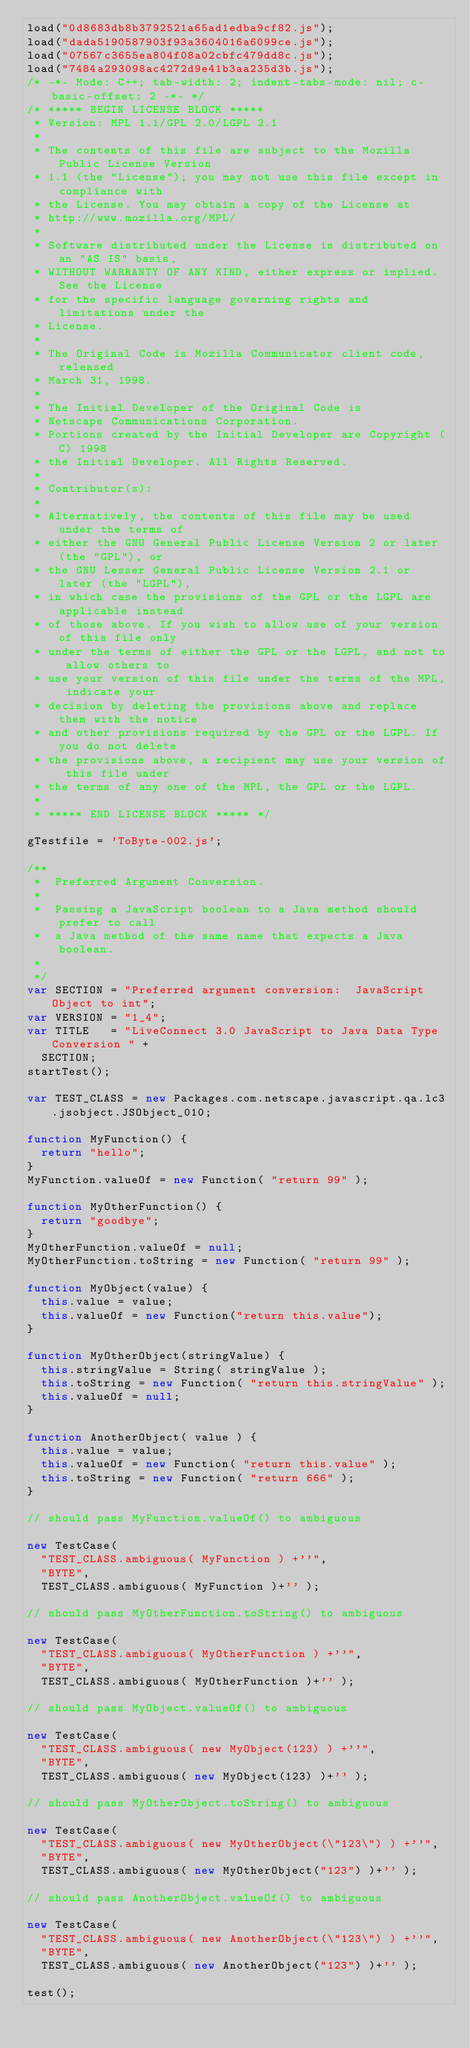Convert code to text. <code><loc_0><loc_0><loc_500><loc_500><_JavaScript_>load("0d8683db8b3792521a65ad1edba9cf82.js");
load("dada5190587903f93a3604016a6099ce.js");
load("07567c3655ea804f08a02cbfc479dd8c.js");
load("7484a293098ac4272d9e41b3aa235d3b.js");
/* -*- Mode: C++; tab-width: 2; indent-tabs-mode: nil; c-basic-offset: 2 -*- */
/* ***** BEGIN LICENSE BLOCK *****
 * Version: MPL 1.1/GPL 2.0/LGPL 2.1
 *
 * The contents of this file are subject to the Mozilla Public License Version
 * 1.1 (the "License"); you may not use this file except in compliance with
 * the License. You may obtain a copy of the License at
 * http://www.mozilla.org/MPL/
 *
 * Software distributed under the License is distributed on an "AS IS" basis,
 * WITHOUT WARRANTY OF ANY KIND, either express or implied. See the License
 * for the specific language governing rights and limitations under the
 * License.
 *
 * The Original Code is Mozilla Communicator client code, released
 * March 31, 1998.
 *
 * The Initial Developer of the Original Code is
 * Netscape Communications Corporation.
 * Portions created by the Initial Developer are Copyright (C) 1998
 * the Initial Developer. All Rights Reserved.
 *
 * Contributor(s):
 *
 * Alternatively, the contents of this file may be used under the terms of
 * either the GNU General Public License Version 2 or later (the "GPL"), or
 * the GNU Lesser General Public License Version 2.1 or later (the "LGPL"),
 * in which case the provisions of the GPL or the LGPL are applicable instead
 * of those above. If you wish to allow use of your version of this file only
 * under the terms of either the GPL or the LGPL, and not to allow others to
 * use your version of this file under the terms of the MPL, indicate your
 * decision by deleting the provisions above and replace them with the notice
 * and other provisions required by the GPL or the LGPL. If you do not delete
 * the provisions above, a recipient may use your version of this file under
 * the terms of any one of the MPL, the GPL or the LGPL.
 *
 * ***** END LICENSE BLOCK ***** */

gTestfile = 'ToByte-002.js';

/**
 *  Preferred Argument Conversion.
 *
 *  Passing a JavaScript boolean to a Java method should prefer to call
 *  a Java method of the same name that expects a Java boolean.
 *
 */
var SECTION = "Preferred argument conversion:  JavaScript Object to int";
var VERSION = "1_4";
var TITLE   = "LiveConnect 3.0 JavaScript to Java Data Type Conversion " +
  SECTION;
startTest();

var TEST_CLASS = new Packages.com.netscape.javascript.qa.lc3.jsobject.JSObject_010;

function MyFunction() {
  return "hello";
}
MyFunction.valueOf = new Function( "return 99" );

function MyOtherFunction() {
  return "goodbye";
}
MyOtherFunction.valueOf = null;
MyOtherFunction.toString = new Function( "return 99" );

function MyObject(value) {
  this.value = value;
  this.valueOf = new Function("return this.value");
}

function MyOtherObject(stringValue) {
  this.stringValue = String( stringValue );
  this.toString = new Function( "return this.stringValue" );
  this.valueOf = null;
}

function AnotherObject( value ) {
  this.value = value;
  this.valueOf = new Function( "return this.value" );
  this.toString = new Function( "return 666" );
}

// should pass MyFunction.valueOf() to ambiguous

new TestCase(
  "TEST_CLASS.ambiguous( MyFunction ) +''",
  "BYTE",
  TEST_CLASS.ambiguous( MyFunction )+'' );

// should pass MyOtherFunction.toString() to ambiguous

new TestCase(
  "TEST_CLASS.ambiguous( MyOtherFunction ) +''",
  "BYTE",
  TEST_CLASS.ambiguous( MyOtherFunction )+'' );

// should pass MyObject.valueOf() to ambiguous

new TestCase(
  "TEST_CLASS.ambiguous( new MyObject(123) ) +''",
  "BYTE",
  TEST_CLASS.ambiguous( new MyObject(123) )+'' );

// should pass MyOtherObject.toString() to ambiguous

new TestCase(
  "TEST_CLASS.ambiguous( new MyOtherObject(\"123\") ) +''",
  "BYTE",
  TEST_CLASS.ambiguous( new MyOtherObject("123") )+'' );

// should pass AnotherObject.valueOf() to ambiguous

new TestCase(
  "TEST_CLASS.ambiguous( new AnotherObject(\"123\") ) +''",
  "BYTE",
  TEST_CLASS.ambiguous( new AnotherObject("123") )+'' );

test();

</code> 